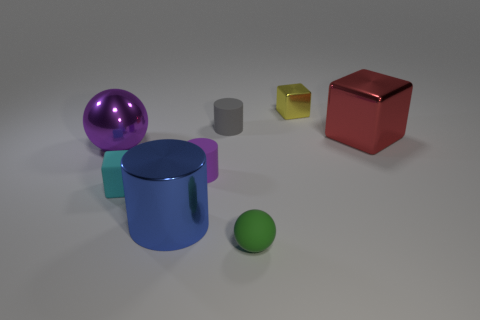Is the material of the big thing in front of the cyan matte object the same as the yellow block?
Offer a terse response. Yes. What is the material of the cube that is behind the large metallic object that is right of the ball that is to the right of the small gray thing?
Provide a short and direct response. Metal. How many other objects are the same shape as the large blue thing?
Offer a very short reply. 2. There is a tiny block that is behind the tiny gray object; what color is it?
Ensure brevity in your answer.  Yellow. How many purple matte objects are on the right side of the small rubber thing in front of the small block in front of the large purple metal sphere?
Offer a very short reply. 0. What number of large metal things are behind the rubber thing on the left side of the large cylinder?
Offer a terse response. 2. What number of blue metallic objects are on the right side of the tiny green sphere?
Ensure brevity in your answer.  0. How many other things are there of the same size as the gray thing?
Your response must be concise. 4. What size is the cyan matte thing that is the same shape as the yellow object?
Provide a succinct answer. Small. There is a big thing right of the green thing; what shape is it?
Give a very brief answer. Cube. 